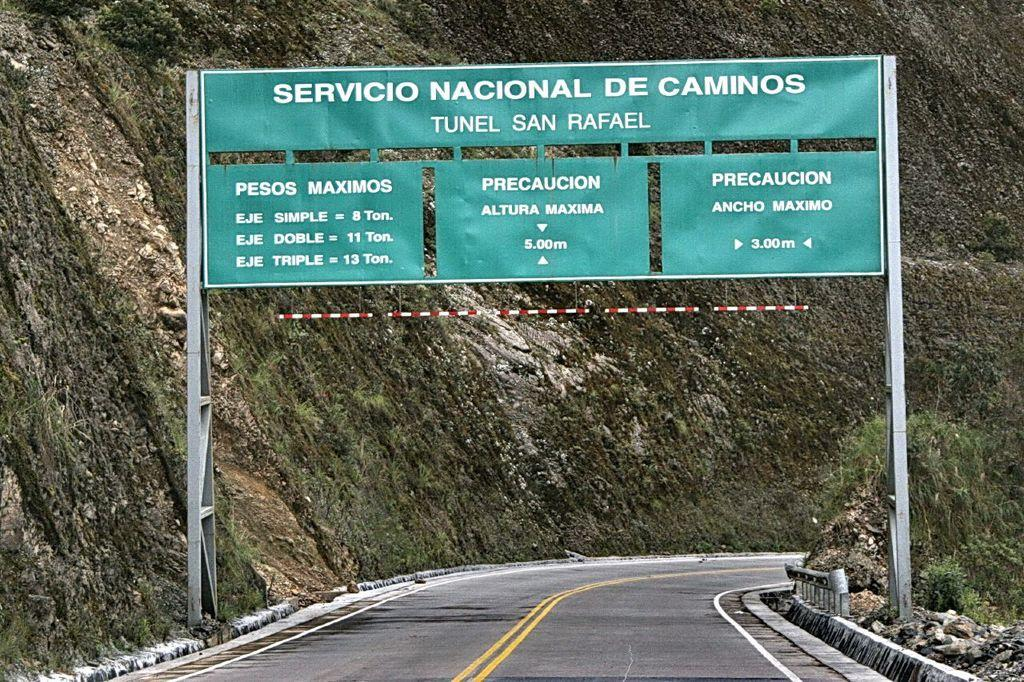What is the main feature of the image? There is a road in the image. What is written or displayed above the road? There is a board with text above the road. How is the board supported or held up? The board is attached to poles. What can be seen in the distance behind the road? There is a mountain visible in the background of the image. What type of creature is pulling the yoke in the image? There is no yoke or creature present in the image. 